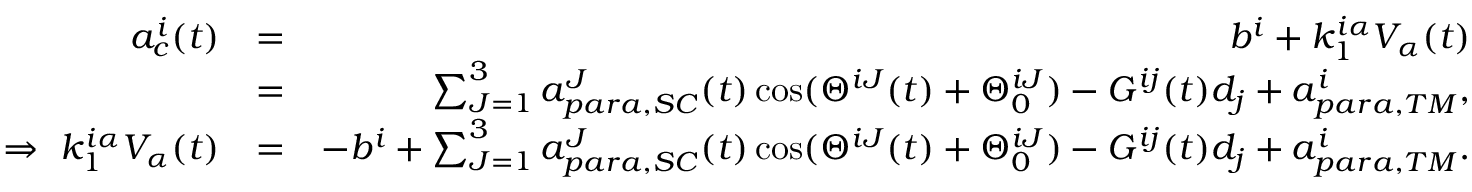Convert formula to latex. <formula><loc_0><loc_0><loc_500><loc_500>\begin{array} { r l r } { a _ { c } ^ { i } ( t ) } & { = } & { b ^ { i } + k _ { 1 } ^ { i \alpha } V _ { \alpha } ( t ) } \\ & { = } & { \sum _ { J = 1 } ^ { 3 } a _ { p a r a , S C } ^ { J } ( t ) \cos ( \Theta ^ { i J } ( t ) + \Theta _ { 0 } ^ { i J } ) - G ^ { i j } ( t ) d _ { j } + a _ { p a r a , T M } ^ { i } , } \\ { \Rightarrow \ k _ { 1 } ^ { i \alpha } V _ { \alpha } ( t ) } & { = } & { - b ^ { i } + \sum _ { J = 1 } ^ { 3 } a _ { p a r a , S C } ^ { J } ( t ) \cos ( \Theta ^ { i J } ( t ) + \Theta _ { 0 } ^ { i J } ) - G ^ { i j } ( t ) d _ { j } + a _ { p a r a , T M } ^ { i } . } \end{array}</formula> 